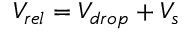Convert formula to latex. <formula><loc_0><loc_0><loc_500><loc_500>V _ { r e l } = V _ { d r o p } + V _ { s }</formula> 